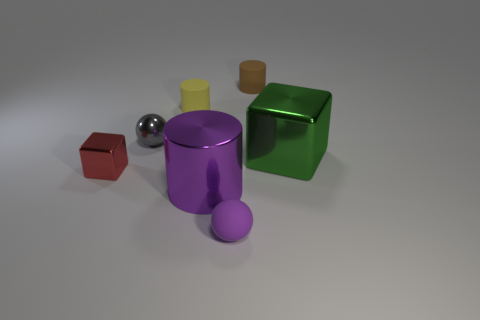Add 3 tiny gray rubber spheres. How many objects exist? 10 Subtract all green cubes. How many gray balls are left? 1 Subtract all purple matte objects. Subtract all small yellow matte objects. How many objects are left? 5 Add 3 tiny red shiny cubes. How many tiny red shiny cubes are left? 4 Add 4 tiny brown matte cylinders. How many tiny brown matte cylinders exist? 5 Subtract all yellow cylinders. How many cylinders are left? 2 Subtract all purple shiny cylinders. How many cylinders are left? 2 Subtract 0 red spheres. How many objects are left? 7 Subtract all balls. How many objects are left? 5 Subtract 2 blocks. How many blocks are left? 0 